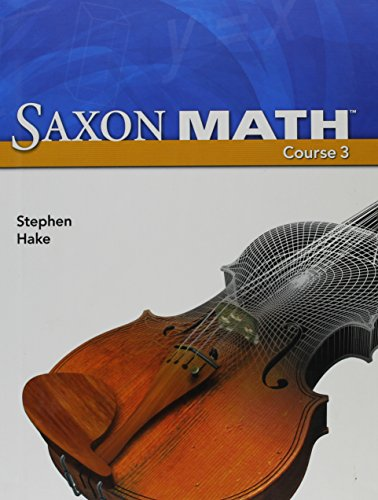What type of book is this? This is an educational textbook specifically designed for mathematics instruction at a middle school level, targeting young teenage students. 